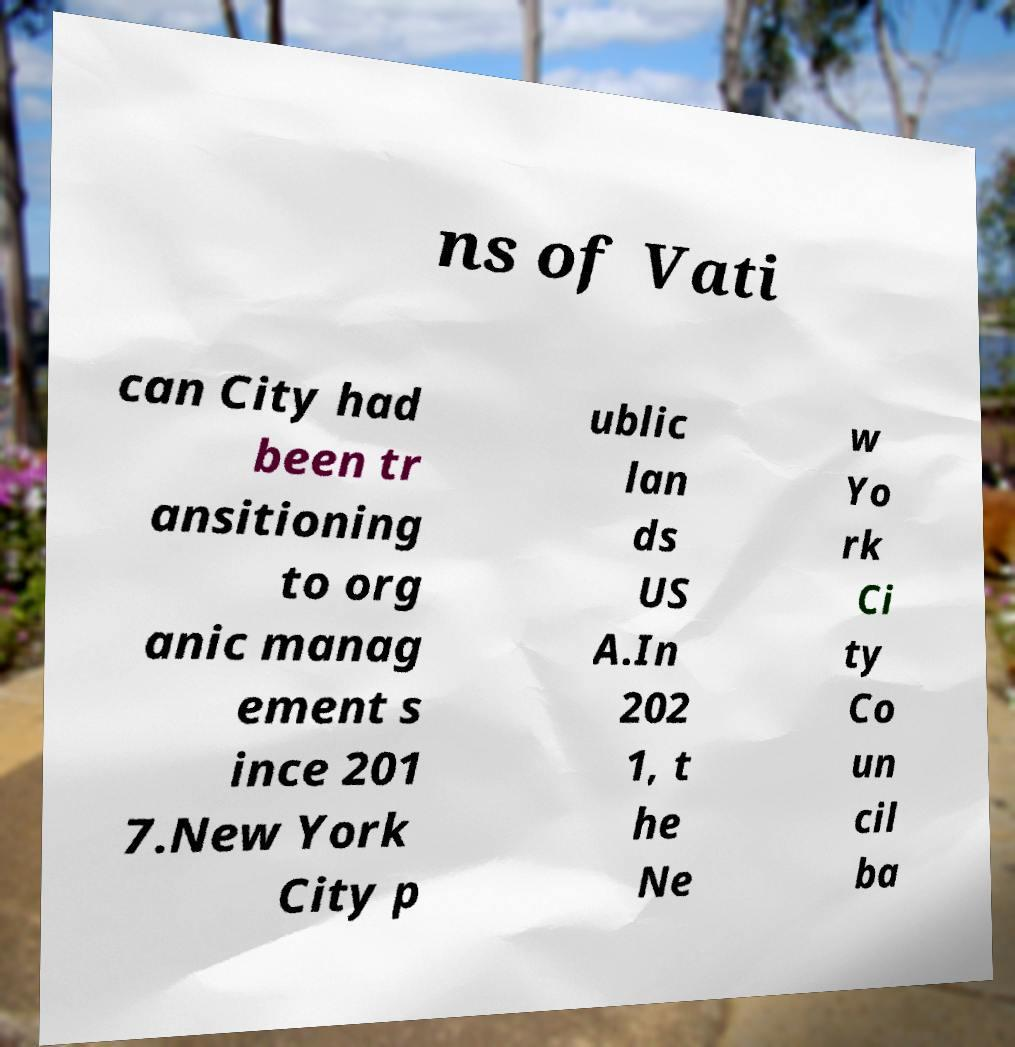Can you read and provide the text displayed in the image?This photo seems to have some interesting text. Can you extract and type it out for me? ns of Vati can City had been tr ansitioning to org anic manag ement s ince 201 7.New York City p ublic lan ds US A.In 202 1, t he Ne w Yo rk Ci ty Co un cil ba 